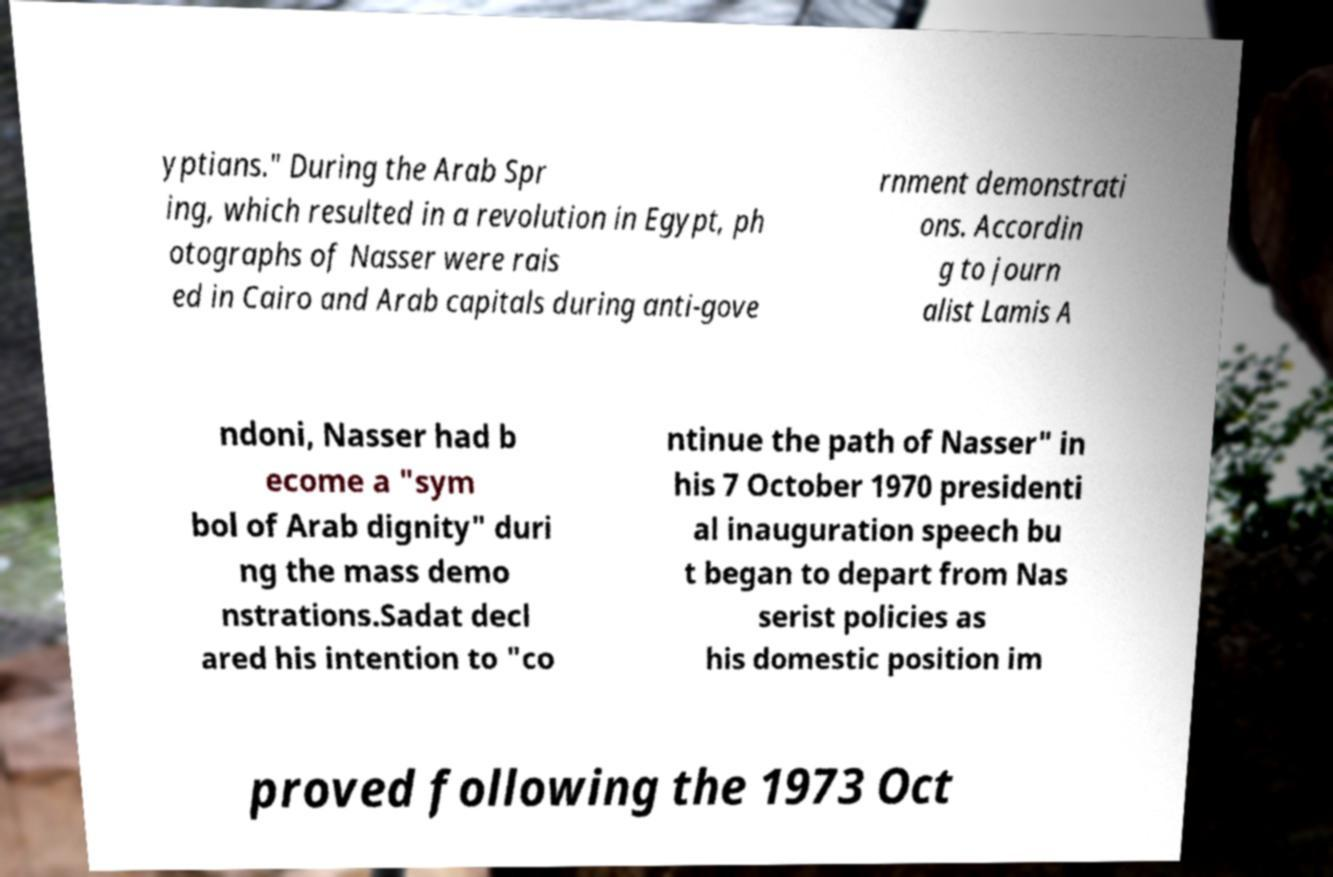Please identify and transcribe the text found in this image. yptians." During the Arab Spr ing, which resulted in a revolution in Egypt, ph otographs of Nasser were rais ed in Cairo and Arab capitals during anti-gove rnment demonstrati ons. Accordin g to journ alist Lamis A ndoni, Nasser had b ecome a "sym bol of Arab dignity" duri ng the mass demo nstrations.Sadat decl ared his intention to "co ntinue the path of Nasser" in his 7 October 1970 presidenti al inauguration speech bu t began to depart from Nas serist policies as his domestic position im proved following the 1973 Oct 